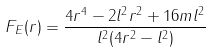Convert formula to latex. <formula><loc_0><loc_0><loc_500><loc_500>F _ { E } ( r ) = \frac { 4 r ^ { 4 } - 2 l ^ { 2 } r ^ { 2 } + 1 6 m l ^ { 2 } } { l ^ { 2 } ( 4 r ^ { 2 } - l ^ { 2 } ) }</formula> 